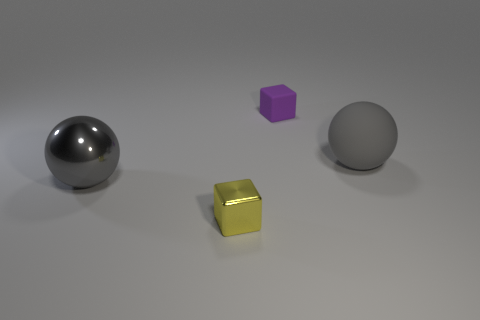There is a big ball right of the purple rubber object; is its color the same as the small shiny object?
Provide a short and direct response. No. What number of things are either small blocks that are behind the yellow cube or balls that are in front of the matte sphere?
Make the answer very short. 2. What number of objects are both behind the small yellow shiny object and in front of the tiny rubber cube?
Make the answer very short. 2. Do the tiny purple cube and the yellow object have the same material?
Your response must be concise. No. There is a shiny thing in front of the large gray thing that is to the left of the small thing that is in front of the large metallic ball; what is its shape?
Provide a succinct answer. Cube. What is the material of the object that is right of the large gray shiny sphere and left of the purple rubber cube?
Keep it short and to the point. Metal. What is the color of the sphere right of the thing behind the big gray ball that is to the right of the metal cube?
Give a very brief answer. Gray. How many purple objects are large shiny things or tiny metallic things?
Offer a terse response. 0. How many other things are the same size as the rubber cube?
Give a very brief answer. 1. What number of tiny objects are there?
Keep it short and to the point. 2. 